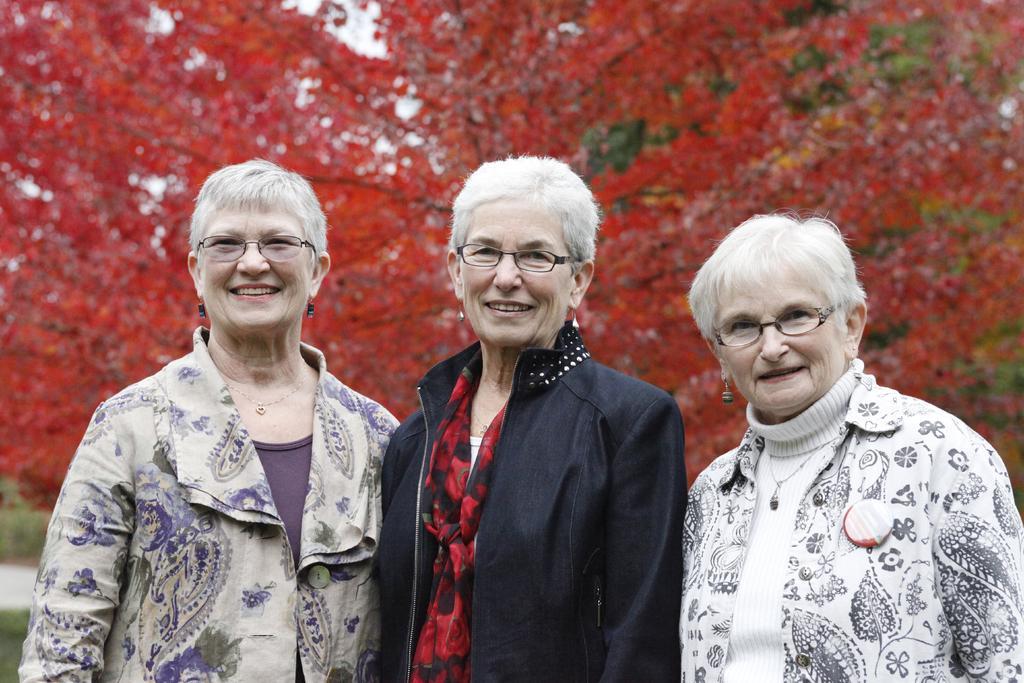In one or two sentences, can you explain what this image depicts? This picture is clicked outside. In the foreground we can see the three persons wearing jackets, spectacles, smiling and standing on the ground. In the background we can see the trees full of leaves. 